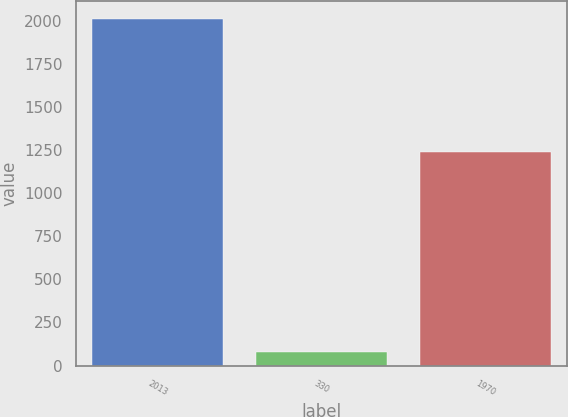Convert chart. <chart><loc_0><loc_0><loc_500><loc_500><bar_chart><fcel>2013<fcel>330<fcel>1970<nl><fcel>2012<fcel>77<fcel>1238<nl></chart> 